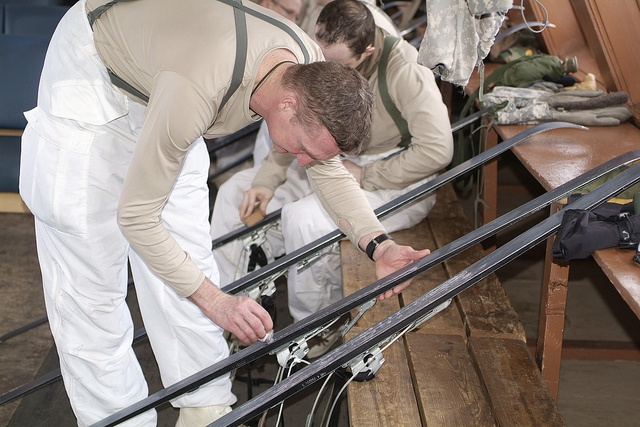Describe the objects in this image and their specific colors. I can see people in black, lightgray, darkgray, and gray tones, people in black, darkgray, lightgray, and gray tones, skis in black, gray, and darkgray tones, skis in black, gray, and darkgray tones, and people in black, darkgray, and gray tones in this image. 